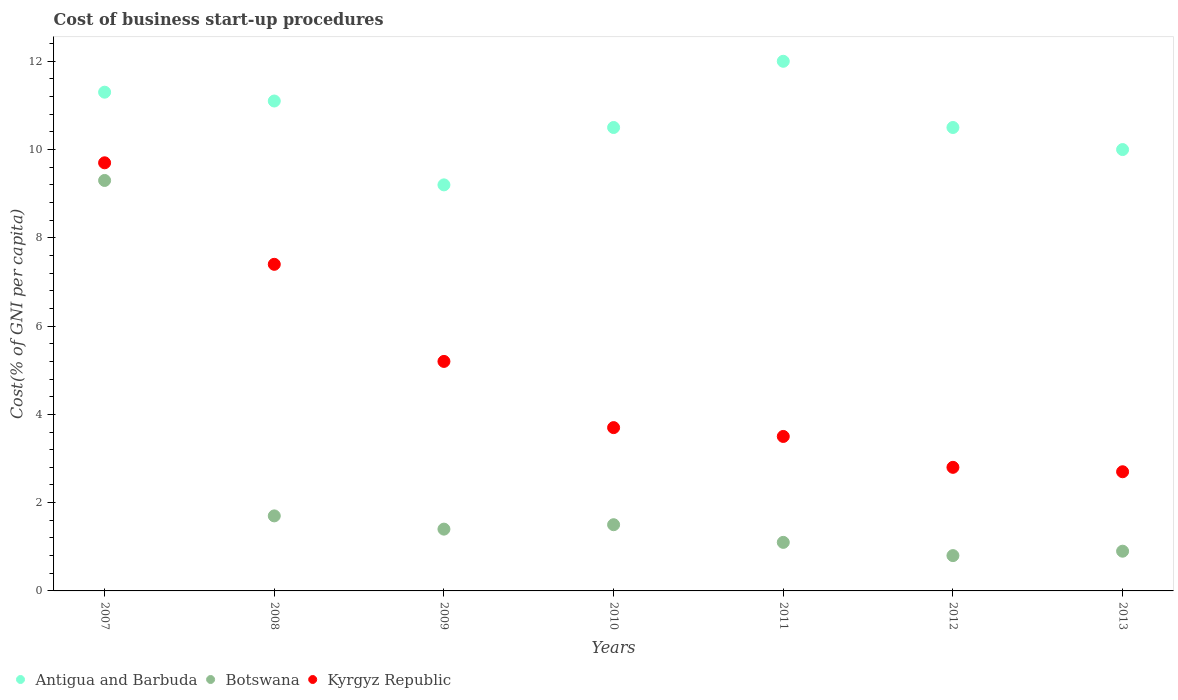How many different coloured dotlines are there?
Provide a succinct answer. 3. What is the cost of business start-up procedures in Antigua and Barbuda in 2008?
Give a very brief answer. 11.1. Across all years, what is the maximum cost of business start-up procedures in Antigua and Barbuda?
Offer a terse response. 12. Across all years, what is the minimum cost of business start-up procedures in Kyrgyz Republic?
Your answer should be very brief. 2.7. In which year was the cost of business start-up procedures in Kyrgyz Republic maximum?
Provide a short and direct response. 2007. In which year was the cost of business start-up procedures in Antigua and Barbuda minimum?
Make the answer very short. 2009. What is the total cost of business start-up procedures in Botswana in the graph?
Ensure brevity in your answer.  16.7. What is the difference between the cost of business start-up procedures in Botswana in 2008 and the cost of business start-up procedures in Kyrgyz Republic in 2007?
Provide a succinct answer. -8. What is the average cost of business start-up procedures in Botswana per year?
Your response must be concise. 2.39. In the year 2008, what is the difference between the cost of business start-up procedures in Antigua and Barbuda and cost of business start-up procedures in Botswana?
Make the answer very short. 9.4. In how many years, is the cost of business start-up procedures in Kyrgyz Republic greater than 2.4 %?
Your response must be concise. 7. What is the ratio of the cost of business start-up procedures in Antigua and Barbuda in 2008 to that in 2011?
Provide a succinct answer. 0.92. Is the difference between the cost of business start-up procedures in Antigua and Barbuda in 2009 and 2011 greater than the difference between the cost of business start-up procedures in Botswana in 2009 and 2011?
Ensure brevity in your answer.  No. What is the difference between the highest and the second highest cost of business start-up procedures in Botswana?
Offer a very short reply. 7.6. What is the difference between the highest and the lowest cost of business start-up procedures in Kyrgyz Republic?
Provide a succinct answer. 7. Is the sum of the cost of business start-up procedures in Antigua and Barbuda in 2010 and 2011 greater than the maximum cost of business start-up procedures in Botswana across all years?
Provide a succinct answer. Yes. Is it the case that in every year, the sum of the cost of business start-up procedures in Botswana and cost of business start-up procedures in Kyrgyz Republic  is greater than the cost of business start-up procedures in Antigua and Barbuda?
Provide a short and direct response. No. Does the cost of business start-up procedures in Kyrgyz Republic monotonically increase over the years?
Your answer should be compact. No. Is the cost of business start-up procedures in Botswana strictly greater than the cost of business start-up procedures in Kyrgyz Republic over the years?
Offer a very short reply. No. How many dotlines are there?
Keep it short and to the point. 3. How many years are there in the graph?
Give a very brief answer. 7. What is the difference between two consecutive major ticks on the Y-axis?
Provide a short and direct response. 2. Does the graph contain any zero values?
Ensure brevity in your answer.  No. Does the graph contain grids?
Your answer should be compact. No. Where does the legend appear in the graph?
Provide a succinct answer. Bottom left. How many legend labels are there?
Offer a terse response. 3. How are the legend labels stacked?
Offer a terse response. Horizontal. What is the title of the graph?
Offer a very short reply. Cost of business start-up procedures. What is the label or title of the X-axis?
Offer a terse response. Years. What is the label or title of the Y-axis?
Provide a succinct answer. Cost(% of GNI per capita). What is the Cost(% of GNI per capita) in Antigua and Barbuda in 2007?
Offer a very short reply. 11.3. What is the Cost(% of GNI per capita) in Antigua and Barbuda in 2008?
Provide a short and direct response. 11.1. What is the Cost(% of GNI per capita) in Botswana in 2009?
Provide a succinct answer. 1.4. What is the Cost(% of GNI per capita) of Kyrgyz Republic in 2009?
Your answer should be very brief. 5.2. What is the Cost(% of GNI per capita) of Antigua and Barbuda in 2010?
Provide a succinct answer. 10.5. What is the Cost(% of GNI per capita) of Botswana in 2010?
Your response must be concise. 1.5. What is the Cost(% of GNI per capita) of Botswana in 2011?
Provide a succinct answer. 1.1. What is the Cost(% of GNI per capita) of Kyrgyz Republic in 2011?
Provide a succinct answer. 3.5. What is the Cost(% of GNI per capita) in Antigua and Barbuda in 2013?
Offer a terse response. 10. What is the Cost(% of GNI per capita) of Botswana in 2013?
Your response must be concise. 0.9. What is the Cost(% of GNI per capita) in Kyrgyz Republic in 2013?
Your answer should be compact. 2.7. Across all years, what is the maximum Cost(% of GNI per capita) in Botswana?
Your answer should be compact. 9.3. What is the total Cost(% of GNI per capita) in Antigua and Barbuda in the graph?
Provide a succinct answer. 74.6. What is the difference between the Cost(% of GNI per capita) in Antigua and Barbuda in 2007 and that in 2009?
Ensure brevity in your answer.  2.1. What is the difference between the Cost(% of GNI per capita) of Kyrgyz Republic in 2007 and that in 2009?
Offer a very short reply. 4.5. What is the difference between the Cost(% of GNI per capita) of Kyrgyz Republic in 2007 and that in 2010?
Provide a succinct answer. 6. What is the difference between the Cost(% of GNI per capita) in Antigua and Barbuda in 2007 and that in 2012?
Offer a terse response. 0.8. What is the difference between the Cost(% of GNI per capita) of Botswana in 2007 and that in 2012?
Ensure brevity in your answer.  8.5. What is the difference between the Cost(% of GNI per capita) of Botswana in 2008 and that in 2010?
Offer a very short reply. 0.2. What is the difference between the Cost(% of GNI per capita) in Antigua and Barbuda in 2008 and that in 2011?
Your answer should be compact. -0.9. What is the difference between the Cost(% of GNI per capita) of Kyrgyz Republic in 2008 and that in 2012?
Your answer should be very brief. 4.6. What is the difference between the Cost(% of GNI per capita) in Botswana in 2008 and that in 2013?
Offer a very short reply. 0.8. What is the difference between the Cost(% of GNI per capita) of Kyrgyz Republic in 2008 and that in 2013?
Your answer should be compact. 4.7. What is the difference between the Cost(% of GNI per capita) in Antigua and Barbuda in 2009 and that in 2010?
Give a very brief answer. -1.3. What is the difference between the Cost(% of GNI per capita) of Kyrgyz Republic in 2009 and that in 2010?
Give a very brief answer. 1.5. What is the difference between the Cost(% of GNI per capita) in Antigua and Barbuda in 2009 and that in 2011?
Provide a short and direct response. -2.8. What is the difference between the Cost(% of GNI per capita) in Antigua and Barbuda in 2009 and that in 2012?
Your answer should be very brief. -1.3. What is the difference between the Cost(% of GNI per capita) in Botswana in 2009 and that in 2012?
Your response must be concise. 0.6. What is the difference between the Cost(% of GNI per capita) of Kyrgyz Republic in 2009 and that in 2012?
Your answer should be very brief. 2.4. What is the difference between the Cost(% of GNI per capita) of Botswana in 2009 and that in 2013?
Provide a short and direct response. 0.5. What is the difference between the Cost(% of GNI per capita) of Antigua and Barbuda in 2010 and that in 2011?
Make the answer very short. -1.5. What is the difference between the Cost(% of GNI per capita) in Kyrgyz Republic in 2010 and that in 2012?
Offer a terse response. 0.9. What is the difference between the Cost(% of GNI per capita) of Antigua and Barbuda in 2010 and that in 2013?
Your response must be concise. 0.5. What is the difference between the Cost(% of GNI per capita) in Botswana in 2010 and that in 2013?
Provide a succinct answer. 0.6. What is the difference between the Cost(% of GNI per capita) of Botswana in 2011 and that in 2012?
Your response must be concise. 0.3. What is the difference between the Cost(% of GNI per capita) in Kyrgyz Republic in 2011 and that in 2012?
Your response must be concise. 0.7. What is the difference between the Cost(% of GNI per capita) of Botswana in 2011 and that in 2013?
Keep it short and to the point. 0.2. What is the difference between the Cost(% of GNI per capita) of Botswana in 2012 and that in 2013?
Provide a short and direct response. -0.1. What is the difference between the Cost(% of GNI per capita) of Botswana in 2007 and the Cost(% of GNI per capita) of Kyrgyz Republic in 2008?
Make the answer very short. 1.9. What is the difference between the Cost(% of GNI per capita) of Antigua and Barbuda in 2007 and the Cost(% of GNI per capita) of Botswana in 2009?
Your answer should be very brief. 9.9. What is the difference between the Cost(% of GNI per capita) of Antigua and Barbuda in 2007 and the Cost(% of GNI per capita) of Kyrgyz Republic in 2010?
Your answer should be very brief. 7.6. What is the difference between the Cost(% of GNI per capita) in Botswana in 2007 and the Cost(% of GNI per capita) in Kyrgyz Republic in 2010?
Your response must be concise. 5.6. What is the difference between the Cost(% of GNI per capita) in Antigua and Barbuda in 2007 and the Cost(% of GNI per capita) in Kyrgyz Republic in 2011?
Provide a short and direct response. 7.8. What is the difference between the Cost(% of GNI per capita) in Antigua and Barbuda in 2007 and the Cost(% of GNI per capita) in Botswana in 2012?
Your response must be concise. 10.5. What is the difference between the Cost(% of GNI per capita) in Antigua and Barbuda in 2007 and the Cost(% of GNI per capita) in Kyrgyz Republic in 2012?
Offer a very short reply. 8.5. What is the difference between the Cost(% of GNI per capita) in Botswana in 2007 and the Cost(% of GNI per capita) in Kyrgyz Republic in 2012?
Offer a very short reply. 6.5. What is the difference between the Cost(% of GNI per capita) in Antigua and Barbuda in 2007 and the Cost(% of GNI per capita) in Kyrgyz Republic in 2013?
Your answer should be very brief. 8.6. What is the difference between the Cost(% of GNI per capita) in Botswana in 2007 and the Cost(% of GNI per capita) in Kyrgyz Republic in 2013?
Offer a very short reply. 6.6. What is the difference between the Cost(% of GNI per capita) in Antigua and Barbuda in 2008 and the Cost(% of GNI per capita) in Kyrgyz Republic in 2010?
Your answer should be compact. 7.4. What is the difference between the Cost(% of GNI per capita) in Botswana in 2008 and the Cost(% of GNI per capita) in Kyrgyz Republic in 2011?
Your response must be concise. -1.8. What is the difference between the Cost(% of GNI per capita) in Antigua and Barbuda in 2008 and the Cost(% of GNI per capita) in Botswana in 2012?
Provide a succinct answer. 10.3. What is the difference between the Cost(% of GNI per capita) in Antigua and Barbuda in 2008 and the Cost(% of GNI per capita) in Kyrgyz Republic in 2012?
Offer a very short reply. 8.3. What is the difference between the Cost(% of GNI per capita) in Botswana in 2008 and the Cost(% of GNI per capita) in Kyrgyz Republic in 2012?
Offer a very short reply. -1.1. What is the difference between the Cost(% of GNI per capita) in Antigua and Barbuda in 2008 and the Cost(% of GNI per capita) in Botswana in 2013?
Ensure brevity in your answer.  10.2. What is the difference between the Cost(% of GNI per capita) in Botswana in 2009 and the Cost(% of GNI per capita) in Kyrgyz Republic in 2010?
Your answer should be compact. -2.3. What is the difference between the Cost(% of GNI per capita) in Antigua and Barbuda in 2009 and the Cost(% of GNI per capita) in Botswana in 2011?
Give a very brief answer. 8.1. What is the difference between the Cost(% of GNI per capita) in Antigua and Barbuda in 2009 and the Cost(% of GNI per capita) in Kyrgyz Republic in 2011?
Keep it short and to the point. 5.7. What is the difference between the Cost(% of GNI per capita) in Antigua and Barbuda in 2009 and the Cost(% of GNI per capita) in Botswana in 2013?
Offer a terse response. 8.3. What is the difference between the Cost(% of GNI per capita) of Botswana in 2009 and the Cost(% of GNI per capita) of Kyrgyz Republic in 2013?
Give a very brief answer. -1.3. What is the difference between the Cost(% of GNI per capita) of Antigua and Barbuda in 2010 and the Cost(% of GNI per capita) of Botswana in 2011?
Make the answer very short. 9.4. What is the difference between the Cost(% of GNI per capita) of Botswana in 2010 and the Cost(% of GNI per capita) of Kyrgyz Republic in 2011?
Keep it short and to the point. -2. What is the difference between the Cost(% of GNI per capita) of Antigua and Barbuda in 2010 and the Cost(% of GNI per capita) of Botswana in 2012?
Your response must be concise. 9.7. What is the difference between the Cost(% of GNI per capita) in Antigua and Barbuda in 2010 and the Cost(% of GNI per capita) in Kyrgyz Republic in 2012?
Your answer should be very brief. 7.7. What is the difference between the Cost(% of GNI per capita) in Antigua and Barbuda in 2010 and the Cost(% of GNI per capita) in Kyrgyz Republic in 2013?
Your answer should be very brief. 7.8. What is the difference between the Cost(% of GNI per capita) of Botswana in 2010 and the Cost(% of GNI per capita) of Kyrgyz Republic in 2013?
Offer a very short reply. -1.2. What is the difference between the Cost(% of GNI per capita) in Antigua and Barbuda in 2011 and the Cost(% of GNI per capita) in Botswana in 2012?
Your answer should be compact. 11.2. What is the difference between the Cost(% of GNI per capita) of Botswana in 2011 and the Cost(% of GNI per capita) of Kyrgyz Republic in 2012?
Your answer should be compact. -1.7. What is the difference between the Cost(% of GNI per capita) in Antigua and Barbuda in 2011 and the Cost(% of GNI per capita) in Botswana in 2013?
Give a very brief answer. 11.1. What is the difference between the Cost(% of GNI per capita) of Antigua and Barbuda in 2012 and the Cost(% of GNI per capita) of Botswana in 2013?
Your response must be concise. 9.6. What is the difference between the Cost(% of GNI per capita) of Antigua and Barbuda in 2012 and the Cost(% of GNI per capita) of Kyrgyz Republic in 2013?
Offer a terse response. 7.8. What is the difference between the Cost(% of GNI per capita) of Botswana in 2012 and the Cost(% of GNI per capita) of Kyrgyz Republic in 2013?
Offer a very short reply. -1.9. What is the average Cost(% of GNI per capita) of Antigua and Barbuda per year?
Your answer should be very brief. 10.66. What is the average Cost(% of GNI per capita) in Botswana per year?
Ensure brevity in your answer.  2.39. What is the average Cost(% of GNI per capita) of Kyrgyz Republic per year?
Offer a terse response. 5. In the year 2007, what is the difference between the Cost(% of GNI per capita) of Antigua and Barbuda and Cost(% of GNI per capita) of Kyrgyz Republic?
Your answer should be compact. 1.6. In the year 2008, what is the difference between the Cost(% of GNI per capita) of Antigua and Barbuda and Cost(% of GNI per capita) of Kyrgyz Republic?
Your answer should be compact. 3.7. In the year 2008, what is the difference between the Cost(% of GNI per capita) of Botswana and Cost(% of GNI per capita) of Kyrgyz Republic?
Provide a short and direct response. -5.7. In the year 2009, what is the difference between the Cost(% of GNI per capita) of Botswana and Cost(% of GNI per capita) of Kyrgyz Republic?
Offer a terse response. -3.8. In the year 2010, what is the difference between the Cost(% of GNI per capita) in Antigua and Barbuda and Cost(% of GNI per capita) in Kyrgyz Republic?
Keep it short and to the point. 6.8. In the year 2012, what is the difference between the Cost(% of GNI per capita) in Botswana and Cost(% of GNI per capita) in Kyrgyz Republic?
Offer a terse response. -2. In the year 2013, what is the difference between the Cost(% of GNI per capita) in Antigua and Barbuda and Cost(% of GNI per capita) in Kyrgyz Republic?
Keep it short and to the point. 7.3. In the year 2013, what is the difference between the Cost(% of GNI per capita) of Botswana and Cost(% of GNI per capita) of Kyrgyz Republic?
Make the answer very short. -1.8. What is the ratio of the Cost(% of GNI per capita) of Botswana in 2007 to that in 2008?
Give a very brief answer. 5.47. What is the ratio of the Cost(% of GNI per capita) of Kyrgyz Republic in 2007 to that in 2008?
Provide a short and direct response. 1.31. What is the ratio of the Cost(% of GNI per capita) in Antigua and Barbuda in 2007 to that in 2009?
Keep it short and to the point. 1.23. What is the ratio of the Cost(% of GNI per capita) of Botswana in 2007 to that in 2009?
Your answer should be compact. 6.64. What is the ratio of the Cost(% of GNI per capita) of Kyrgyz Republic in 2007 to that in 2009?
Keep it short and to the point. 1.87. What is the ratio of the Cost(% of GNI per capita) of Antigua and Barbuda in 2007 to that in 2010?
Your response must be concise. 1.08. What is the ratio of the Cost(% of GNI per capita) of Botswana in 2007 to that in 2010?
Provide a succinct answer. 6.2. What is the ratio of the Cost(% of GNI per capita) in Kyrgyz Republic in 2007 to that in 2010?
Keep it short and to the point. 2.62. What is the ratio of the Cost(% of GNI per capita) of Antigua and Barbuda in 2007 to that in 2011?
Keep it short and to the point. 0.94. What is the ratio of the Cost(% of GNI per capita) in Botswana in 2007 to that in 2011?
Provide a succinct answer. 8.45. What is the ratio of the Cost(% of GNI per capita) of Kyrgyz Republic in 2007 to that in 2011?
Keep it short and to the point. 2.77. What is the ratio of the Cost(% of GNI per capita) in Antigua and Barbuda in 2007 to that in 2012?
Keep it short and to the point. 1.08. What is the ratio of the Cost(% of GNI per capita) of Botswana in 2007 to that in 2012?
Make the answer very short. 11.62. What is the ratio of the Cost(% of GNI per capita) of Kyrgyz Republic in 2007 to that in 2012?
Provide a short and direct response. 3.46. What is the ratio of the Cost(% of GNI per capita) in Antigua and Barbuda in 2007 to that in 2013?
Your answer should be very brief. 1.13. What is the ratio of the Cost(% of GNI per capita) of Botswana in 2007 to that in 2013?
Your answer should be very brief. 10.33. What is the ratio of the Cost(% of GNI per capita) of Kyrgyz Republic in 2007 to that in 2013?
Keep it short and to the point. 3.59. What is the ratio of the Cost(% of GNI per capita) of Antigua and Barbuda in 2008 to that in 2009?
Your answer should be compact. 1.21. What is the ratio of the Cost(% of GNI per capita) of Botswana in 2008 to that in 2009?
Your answer should be very brief. 1.21. What is the ratio of the Cost(% of GNI per capita) in Kyrgyz Republic in 2008 to that in 2009?
Offer a terse response. 1.42. What is the ratio of the Cost(% of GNI per capita) in Antigua and Barbuda in 2008 to that in 2010?
Your answer should be compact. 1.06. What is the ratio of the Cost(% of GNI per capita) in Botswana in 2008 to that in 2010?
Offer a terse response. 1.13. What is the ratio of the Cost(% of GNI per capita) of Kyrgyz Republic in 2008 to that in 2010?
Keep it short and to the point. 2. What is the ratio of the Cost(% of GNI per capita) of Antigua and Barbuda in 2008 to that in 2011?
Your response must be concise. 0.93. What is the ratio of the Cost(% of GNI per capita) in Botswana in 2008 to that in 2011?
Ensure brevity in your answer.  1.55. What is the ratio of the Cost(% of GNI per capita) of Kyrgyz Republic in 2008 to that in 2011?
Provide a succinct answer. 2.11. What is the ratio of the Cost(% of GNI per capita) in Antigua and Barbuda in 2008 to that in 2012?
Your answer should be compact. 1.06. What is the ratio of the Cost(% of GNI per capita) in Botswana in 2008 to that in 2012?
Your response must be concise. 2.12. What is the ratio of the Cost(% of GNI per capita) of Kyrgyz Republic in 2008 to that in 2012?
Your answer should be very brief. 2.64. What is the ratio of the Cost(% of GNI per capita) in Antigua and Barbuda in 2008 to that in 2013?
Provide a short and direct response. 1.11. What is the ratio of the Cost(% of GNI per capita) in Botswana in 2008 to that in 2013?
Your answer should be very brief. 1.89. What is the ratio of the Cost(% of GNI per capita) in Kyrgyz Republic in 2008 to that in 2013?
Provide a succinct answer. 2.74. What is the ratio of the Cost(% of GNI per capita) in Antigua and Barbuda in 2009 to that in 2010?
Ensure brevity in your answer.  0.88. What is the ratio of the Cost(% of GNI per capita) of Botswana in 2009 to that in 2010?
Make the answer very short. 0.93. What is the ratio of the Cost(% of GNI per capita) of Kyrgyz Republic in 2009 to that in 2010?
Give a very brief answer. 1.41. What is the ratio of the Cost(% of GNI per capita) in Antigua and Barbuda in 2009 to that in 2011?
Give a very brief answer. 0.77. What is the ratio of the Cost(% of GNI per capita) of Botswana in 2009 to that in 2011?
Make the answer very short. 1.27. What is the ratio of the Cost(% of GNI per capita) in Kyrgyz Republic in 2009 to that in 2011?
Provide a short and direct response. 1.49. What is the ratio of the Cost(% of GNI per capita) in Antigua and Barbuda in 2009 to that in 2012?
Provide a short and direct response. 0.88. What is the ratio of the Cost(% of GNI per capita) of Kyrgyz Republic in 2009 to that in 2012?
Offer a very short reply. 1.86. What is the ratio of the Cost(% of GNI per capita) of Antigua and Barbuda in 2009 to that in 2013?
Give a very brief answer. 0.92. What is the ratio of the Cost(% of GNI per capita) of Botswana in 2009 to that in 2013?
Ensure brevity in your answer.  1.56. What is the ratio of the Cost(% of GNI per capita) of Kyrgyz Republic in 2009 to that in 2013?
Offer a terse response. 1.93. What is the ratio of the Cost(% of GNI per capita) of Antigua and Barbuda in 2010 to that in 2011?
Make the answer very short. 0.88. What is the ratio of the Cost(% of GNI per capita) in Botswana in 2010 to that in 2011?
Offer a terse response. 1.36. What is the ratio of the Cost(% of GNI per capita) of Kyrgyz Republic in 2010 to that in 2011?
Provide a succinct answer. 1.06. What is the ratio of the Cost(% of GNI per capita) of Botswana in 2010 to that in 2012?
Offer a terse response. 1.88. What is the ratio of the Cost(% of GNI per capita) in Kyrgyz Republic in 2010 to that in 2012?
Provide a short and direct response. 1.32. What is the ratio of the Cost(% of GNI per capita) in Antigua and Barbuda in 2010 to that in 2013?
Your response must be concise. 1.05. What is the ratio of the Cost(% of GNI per capita) of Botswana in 2010 to that in 2013?
Your response must be concise. 1.67. What is the ratio of the Cost(% of GNI per capita) in Kyrgyz Republic in 2010 to that in 2013?
Provide a short and direct response. 1.37. What is the ratio of the Cost(% of GNI per capita) in Antigua and Barbuda in 2011 to that in 2012?
Give a very brief answer. 1.14. What is the ratio of the Cost(% of GNI per capita) of Botswana in 2011 to that in 2012?
Give a very brief answer. 1.38. What is the ratio of the Cost(% of GNI per capita) of Botswana in 2011 to that in 2013?
Keep it short and to the point. 1.22. What is the ratio of the Cost(% of GNI per capita) of Kyrgyz Republic in 2011 to that in 2013?
Offer a very short reply. 1.3. What is the ratio of the Cost(% of GNI per capita) of Antigua and Barbuda in 2012 to that in 2013?
Your answer should be compact. 1.05. What is the ratio of the Cost(% of GNI per capita) of Kyrgyz Republic in 2012 to that in 2013?
Make the answer very short. 1.04. What is the difference between the highest and the second highest Cost(% of GNI per capita) of Botswana?
Your response must be concise. 7.6. What is the difference between the highest and the second highest Cost(% of GNI per capita) of Kyrgyz Republic?
Offer a very short reply. 2.3. What is the difference between the highest and the lowest Cost(% of GNI per capita) in Antigua and Barbuda?
Provide a short and direct response. 2.8. What is the difference between the highest and the lowest Cost(% of GNI per capita) in Botswana?
Provide a short and direct response. 8.5. 